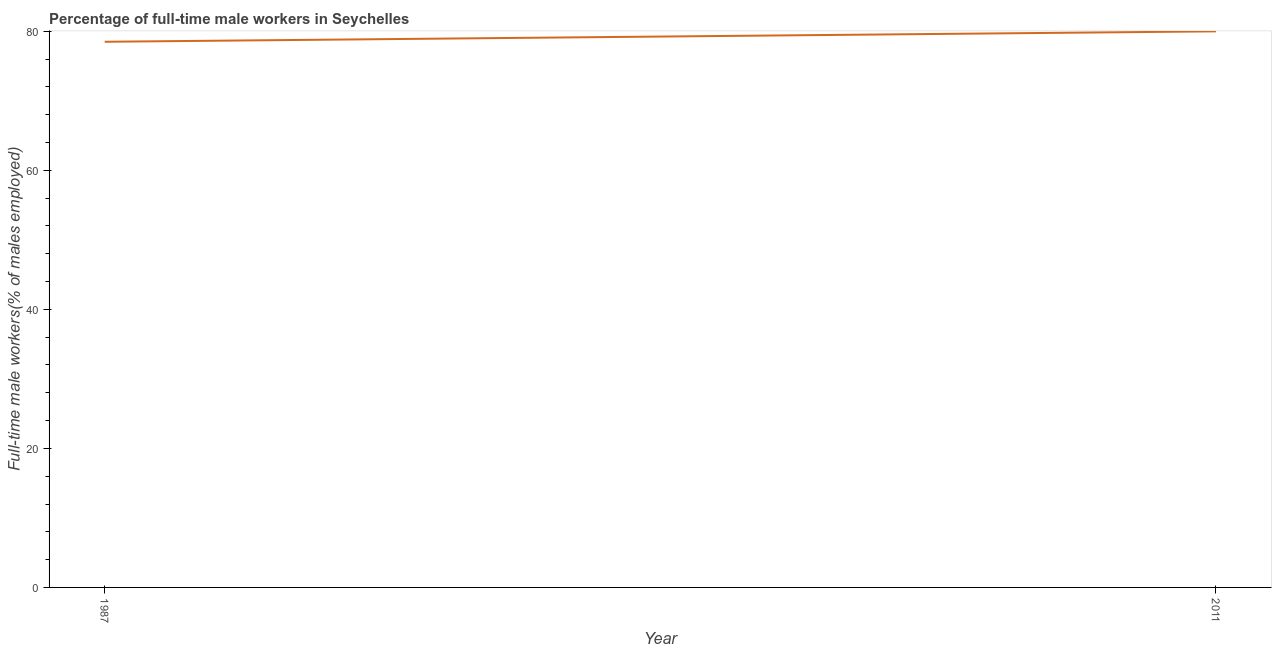What is the percentage of full-time male workers in 2011?
Provide a succinct answer. 80. Across all years, what is the minimum percentage of full-time male workers?
Keep it short and to the point. 78.5. In which year was the percentage of full-time male workers maximum?
Ensure brevity in your answer.  2011. In which year was the percentage of full-time male workers minimum?
Keep it short and to the point. 1987. What is the sum of the percentage of full-time male workers?
Offer a very short reply. 158.5. What is the difference between the percentage of full-time male workers in 1987 and 2011?
Give a very brief answer. -1.5. What is the average percentage of full-time male workers per year?
Your response must be concise. 79.25. What is the median percentage of full-time male workers?
Make the answer very short. 79.25. Do a majority of the years between 2011 and 1987 (inclusive) have percentage of full-time male workers greater than 20 %?
Your answer should be very brief. No. What is the ratio of the percentage of full-time male workers in 1987 to that in 2011?
Provide a short and direct response. 0.98. Is the percentage of full-time male workers in 1987 less than that in 2011?
Ensure brevity in your answer.  Yes. How many years are there in the graph?
Ensure brevity in your answer.  2. What is the difference between two consecutive major ticks on the Y-axis?
Give a very brief answer. 20. Are the values on the major ticks of Y-axis written in scientific E-notation?
Make the answer very short. No. Does the graph contain any zero values?
Keep it short and to the point. No. Does the graph contain grids?
Provide a succinct answer. No. What is the title of the graph?
Make the answer very short. Percentage of full-time male workers in Seychelles. What is the label or title of the Y-axis?
Provide a succinct answer. Full-time male workers(% of males employed). What is the Full-time male workers(% of males employed) in 1987?
Make the answer very short. 78.5. What is the Full-time male workers(% of males employed) in 2011?
Your answer should be compact. 80. What is the ratio of the Full-time male workers(% of males employed) in 1987 to that in 2011?
Your answer should be very brief. 0.98. 